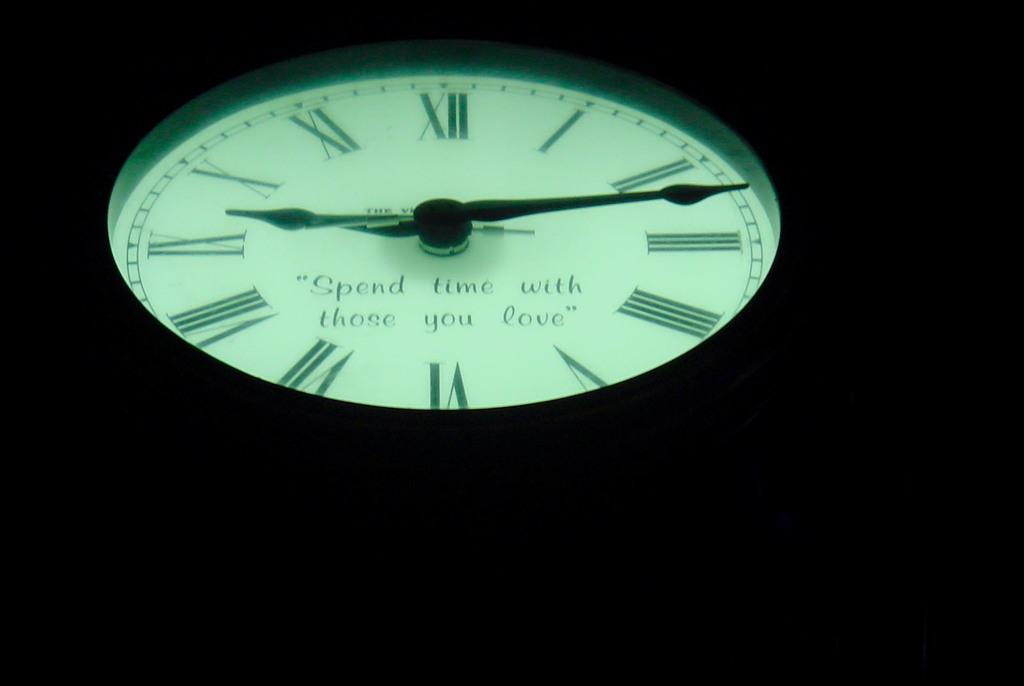<image>
Relay a brief, clear account of the picture shown. Face of a clock which says "Spend time with those you love". 